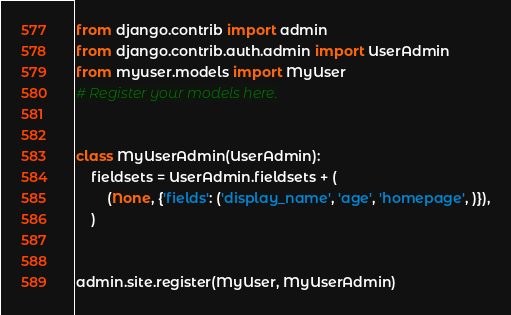<code> <loc_0><loc_0><loc_500><loc_500><_Python_>from django.contrib import admin
from django.contrib.auth.admin import UserAdmin
from myuser.models import MyUser
# Register your models here.


class MyUserAdmin(UserAdmin):
    fieldsets = UserAdmin.fieldsets + (
        (None, {'fields': ('display_name', 'age', 'homepage', )}),
    )


admin.site.register(MyUser, MyUserAdmin)
</code> 